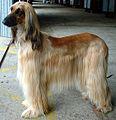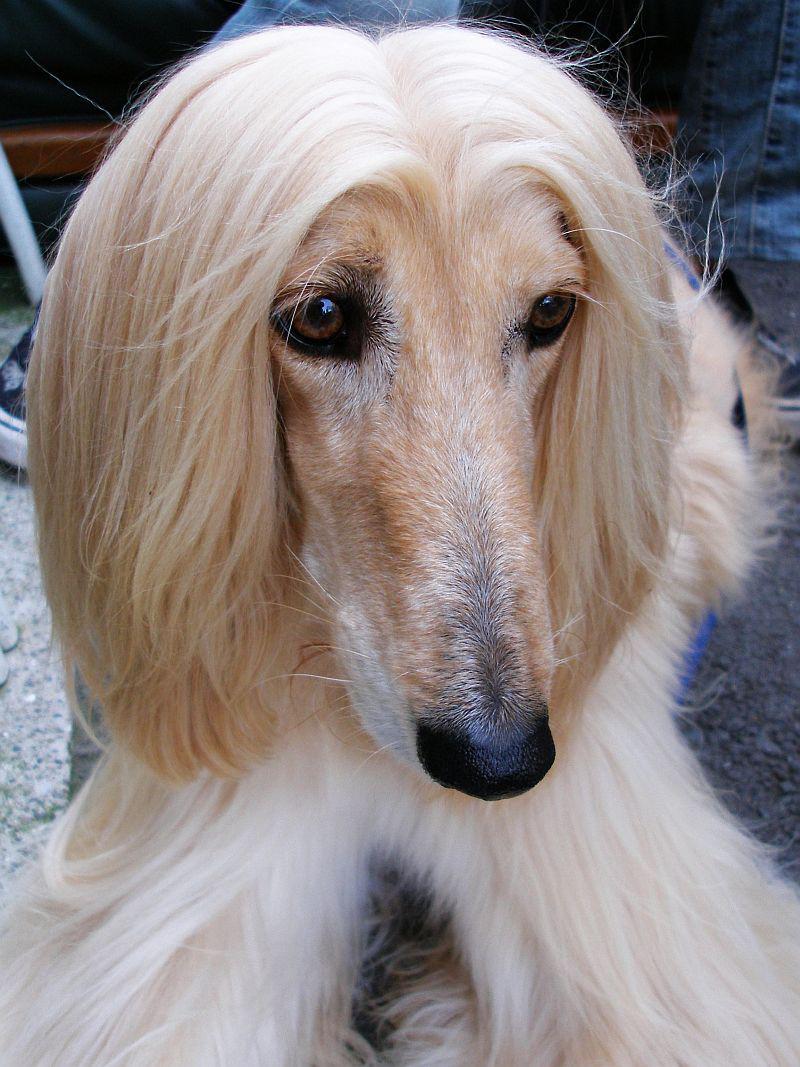The first image is the image on the left, the second image is the image on the right. For the images displayed, is the sentence "An image features an afghan hound on green grass." factually correct? Answer yes or no. No. 